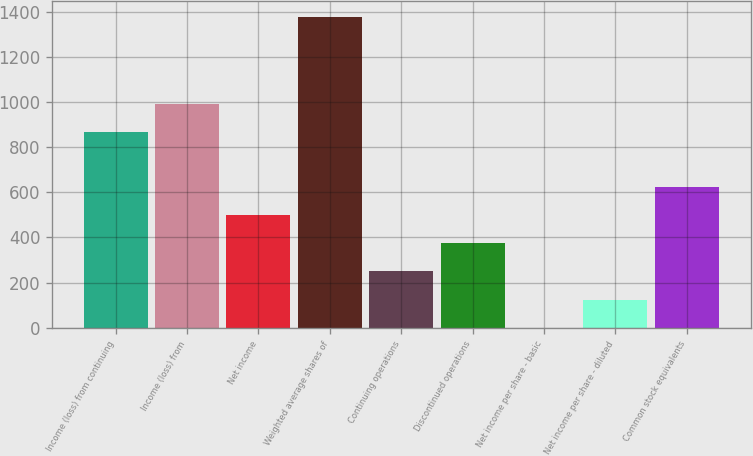Convert chart. <chart><loc_0><loc_0><loc_500><loc_500><bar_chart><fcel>Income (loss) from continuing<fcel>Income (loss) from<fcel>Net income<fcel>Weighted average shares of<fcel>Continuing operations<fcel>Discontinued operations<fcel>Net income per share - basic<fcel>Net income per share - diluted<fcel>Common stock equivalents<nl><fcel>865<fcel>990.1<fcel>500.44<fcel>1376.1<fcel>250.24<fcel>375.34<fcel>0.04<fcel>125.14<fcel>625.54<nl></chart> 